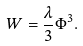<formula> <loc_0><loc_0><loc_500><loc_500>W = \frac { \lambda } { 3 } \Phi ^ { 3 } .</formula> 